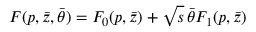<formula> <loc_0><loc_0><loc_500><loc_500>F ( p , \bar { z } , \bar { \theta } ) = F _ { 0 } ( p , \bar { z } ) + \sqrt { s } \, \bar { \theta } F _ { 1 } ( p , \bar { z } )</formula> 